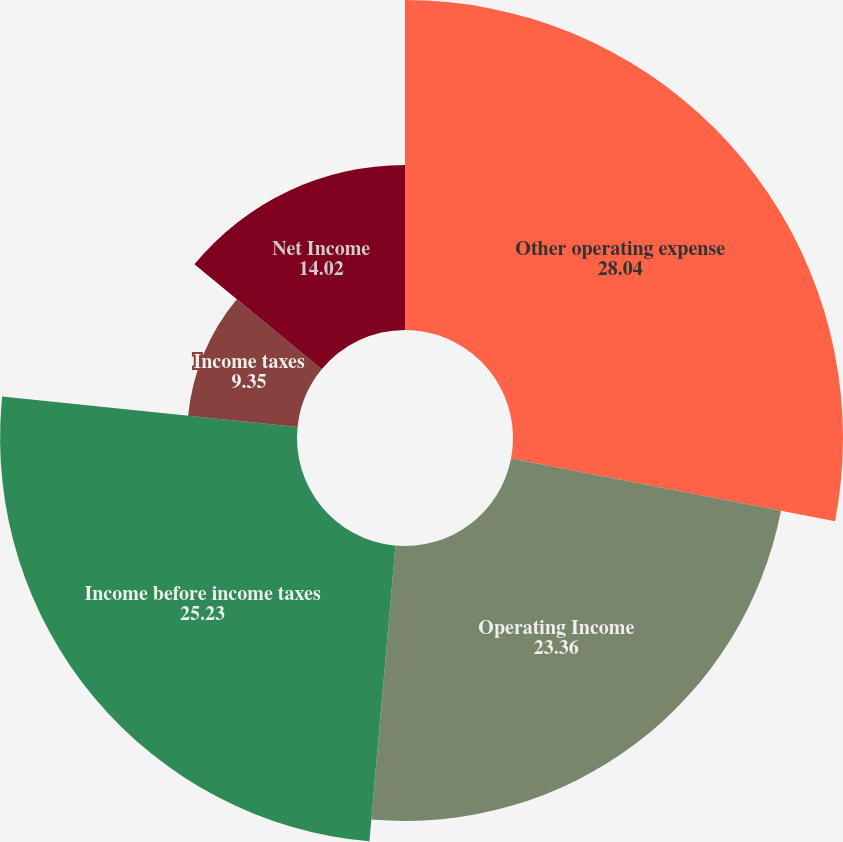<chart> <loc_0><loc_0><loc_500><loc_500><pie_chart><fcel>Other operating expense<fcel>Operating Income<fcel>Income before income taxes<fcel>Income taxes<fcel>Net Income<nl><fcel>28.04%<fcel>23.36%<fcel>25.23%<fcel>9.35%<fcel>14.02%<nl></chart> 